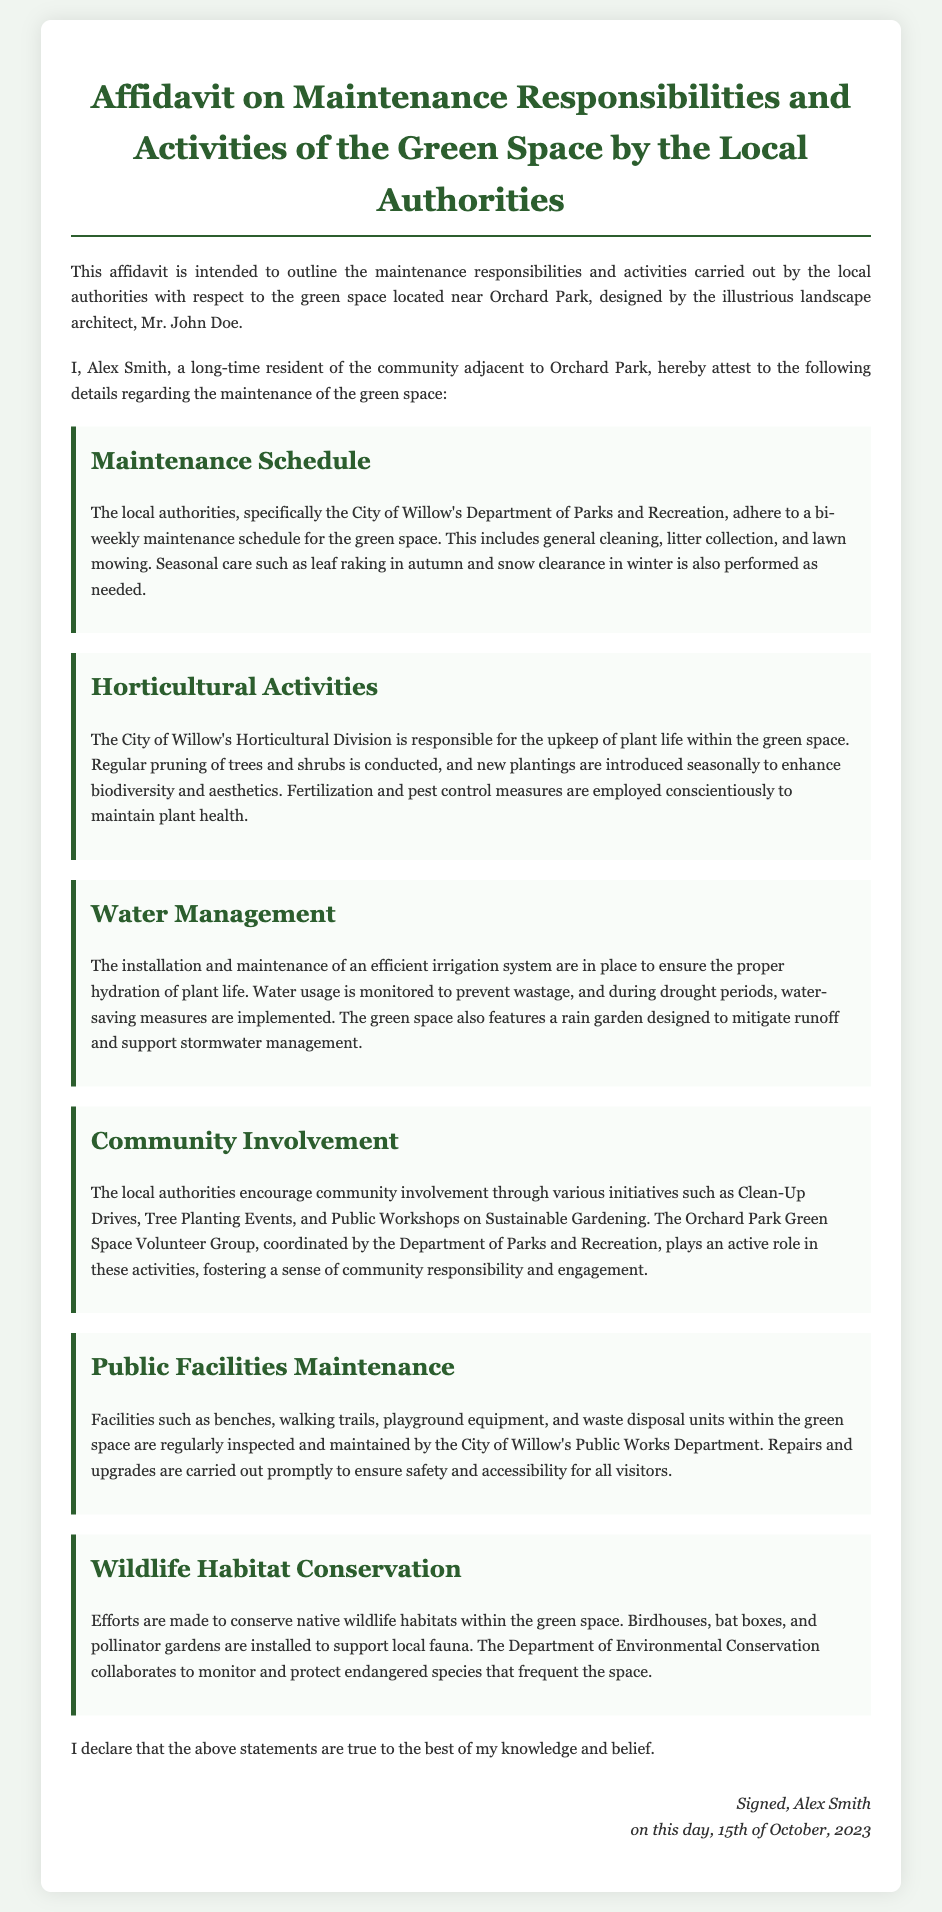What is the maintenance schedule frequency? The document states that the local authorities adhere to a bi-weekly maintenance schedule.
Answer: bi-weekly Who is responsible for horticultural activities? The document indicates that the City of Willow's Horticultural Division is responsible for plant upkeep.
Answer: City of Willow's Horticultural Division What date was the affidavit signed? The affidavit mentions the signing date at the bottom of the document.
Answer: 15th of October, 2023 What types of community involvement initiatives are mentioned? The document lists Clean-Up Drives, Tree Planting Events, and Public Workshops on Sustainable Gardening as initiatives.
Answer: Clean-Up Drives, Tree Planting Events, Public Workshops What facility maintenance is conducted by the Public Works Department? The document explains that benches, walking trails, playground equipment, and waste disposal units are maintained.
Answer: benches, walking trails, playground equipment, waste disposal units What is featured to support stormwater management? The document states that a rain garden is featured to support stormwater management.
Answer: rain garden What organization collaborates for wildlife habitat conservation? The document specifies that the Department of Environmental Conservation collaborates for conservation efforts.
Answer: Department of Environmental Conservation What type of document is this affidavit? The document outlines responsibilities and activities concerning green space maintenance by local authorities.
Answer: Affidavit on Maintenance Responsibilities and Activities 